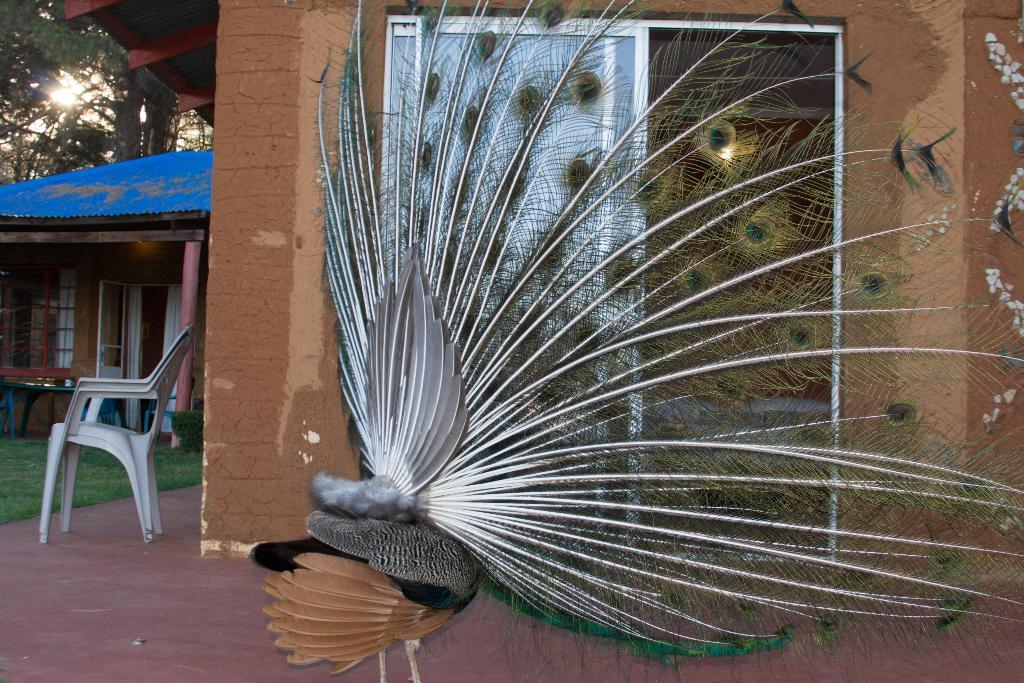What is the peacock doing in the image? The peacock is opening its feathers in the image. Can you describe the furniture in the image? There is a chair beside a wall in the image. What color is the roof top and door of the house? The house has a blue roof top and door. What can be seen in the distance in the image? Trees are visible in the distance. What type of underwear is the actor wearing in the image? There is no actor or underwear present in the image; it features a peacock opening its feathers and a house with a blue roof top and door. What is the peacock doing in outer space in the image? The image does not depict outer space or a peacock in space; it shows a peacock opening its feathers on the ground. 